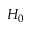Convert formula to latex. <formula><loc_0><loc_0><loc_500><loc_500>H _ { 0 }</formula> 